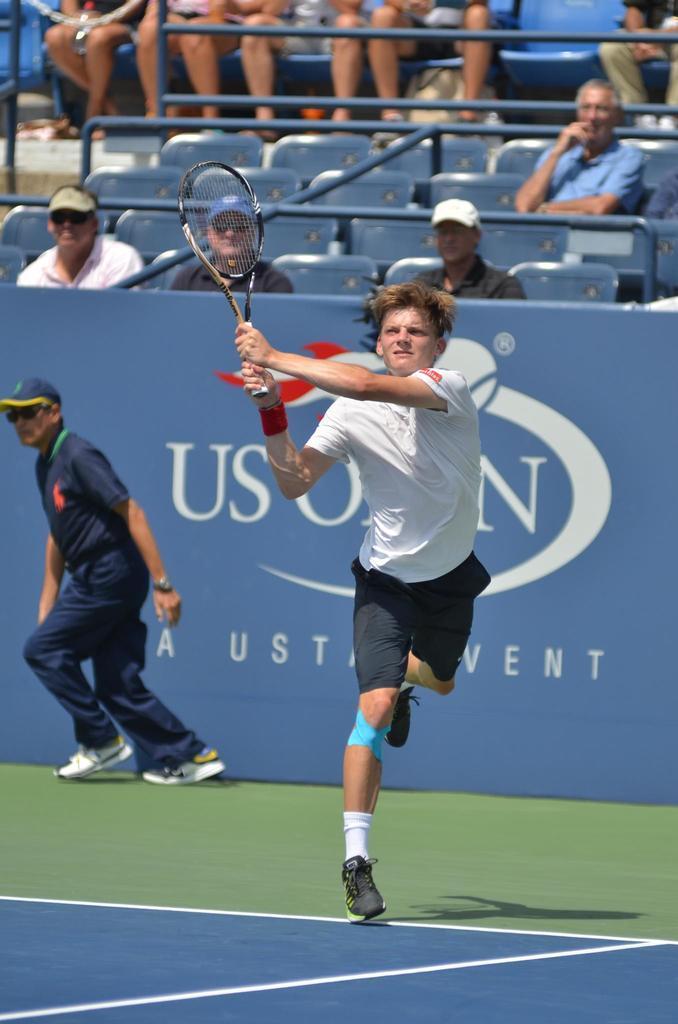Describe this image in one or two sentences. In this image I can see a man is is holding a bat in his hand and behind this man there are few people who are sitting on a chair and the person on the left side is walking and he is wearing a hat and glasses. 